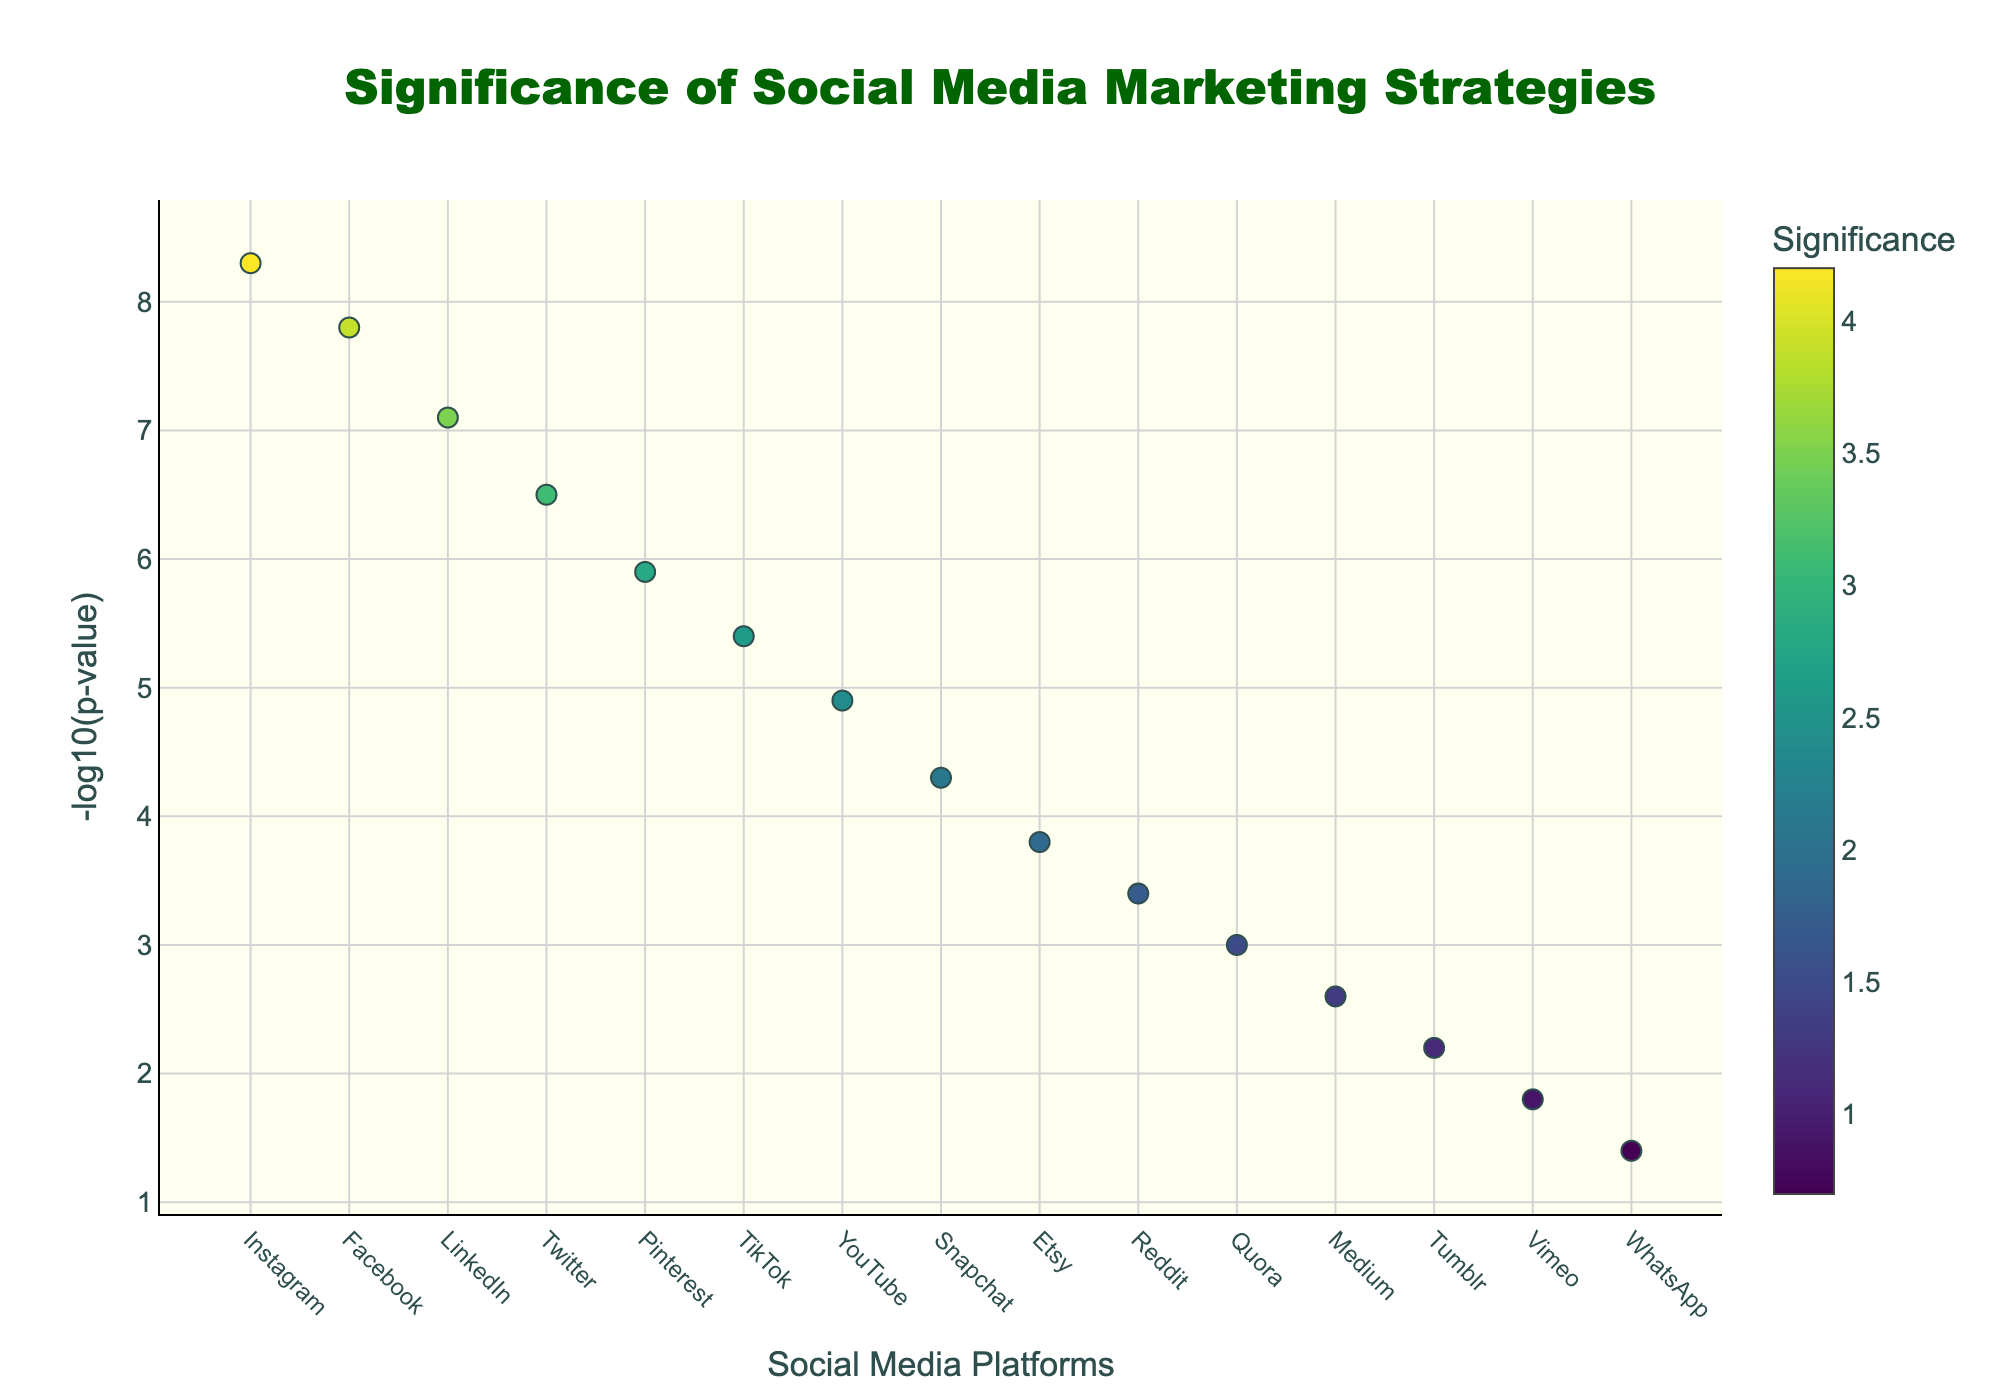What is the title of the figure? The title of the figure is prominently located at the top center. By reading it, you can confirm the title is "Significance of Social Media Marketing Strategies".
Answer: Significance of Social Media Marketing Strategies Which social media platform has the highest -log10(p-value)? By looking at the markers plotted on the y-axis, the platform with the highest y-value represents the highest -log10(p-value). In this case, Instagram has the highest -log10(p-value) of 8.3.
Answer: Instagram What is the y-axis label in the figure? The y-axis label is situated vertically along the left side of the plot. By examining the figure, it is clear that the y-axis is labeled as "-log10(p-value)".
Answer: -log10(p-value) Which platform has the lowest significance, and what is its -log10(p-value)? The platform with the smallest marker or the lowest y-value indicates the lowest significance. By observing the plot, WhatsApp has the lowest significance with a -log10(p-value) of 1.4.
Answer: WhatsApp, 1.4 Compare the significance of LinkedIn and TikTok by their -log10(p-value). Which one is more significant? To compare the two platforms, we look at their respective y-values. LinkedIn's -log10(p-value) is 7.1, while TikTok's is 5.4. Since a higher -log10(p-value) indicates greater significance, LinkedIn is more significant than TikTok.
Answer: LinkedIn How many platforms have a -log10(p-value) greater than 5? Count the number of markers that are positioned above the y-value of 5. By doing so, you find that there are five platforms with a -log10(p-value) greater than 5: Instagram, Facebook, LinkedIn, Twitter, and Pinterest.
Answer: 5 What is the range of the significance values represented in the color scale? The color scale indicates the range of significance values used to color the markers. By looking at the color bar alongside the plot, you can see the range goes from 0.7 (darkest color) to 4.2 (lightest color).
Answer: 0.7 to 4.2 Which platforms are colored the lightest and the darkest, and what does this indicate about their significance? The lightest colored platform corresponds to the highest significance, while the darkest colored platform corresponds to the lowest significance. Instagram is the lightest and WhatsApp is the darkest, indicating Instagram has the highest significance and WhatsApp the lowest.
Answer: Instagram (lightest), WhatsApp (darkest) What is the difference in -log10(p-value) between Facebook and YouTube? To find this, subtract the -log10(p-value) of YouTube from that of Facebook. Facebook has a -log10(p-value) of 7.8 and YouTube has 4.9. The difference is 7.8 - 4.9 = 2.9.
Answer: 2.9 